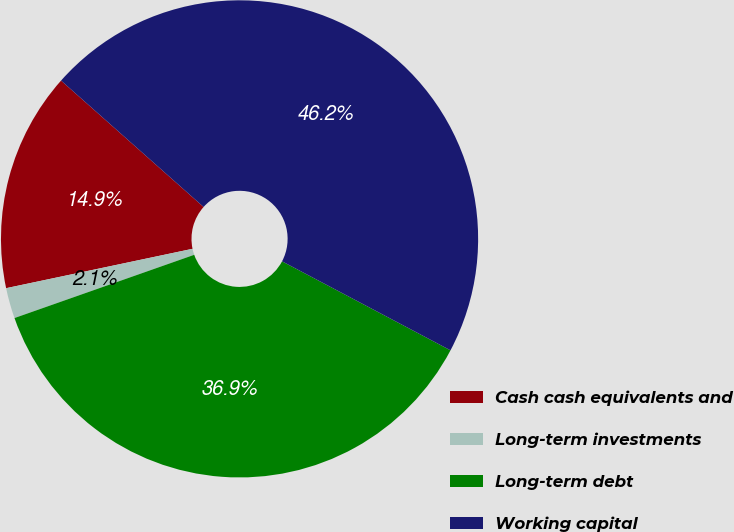<chart> <loc_0><loc_0><loc_500><loc_500><pie_chart><fcel>Cash cash equivalents and<fcel>Long-term investments<fcel>Long-term debt<fcel>Working capital<nl><fcel>14.86%<fcel>2.07%<fcel>36.88%<fcel>46.19%<nl></chart> 